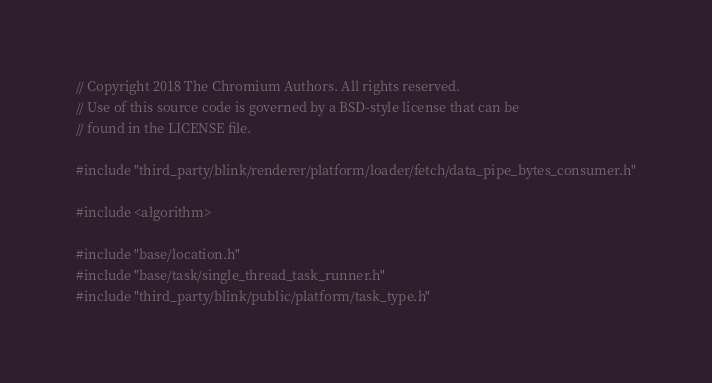<code> <loc_0><loc_0><loc_500><loc_500><_C++_>// Copyright 2018 The Chromium Authors. All rights reserved.
// Use of this source code is governed by a BSD-style license that can be
// found in the LICENSE file.

#include "third_party/blink/renderer/platform/loader/fetch/data_pipe_bytes_consumer.h"

#include <algorithm>

#include "base/location.h"
#include "base/task/single_thread_task_runner.h"
#include "third_party/blink/public/platform/task_type.h"</code> 